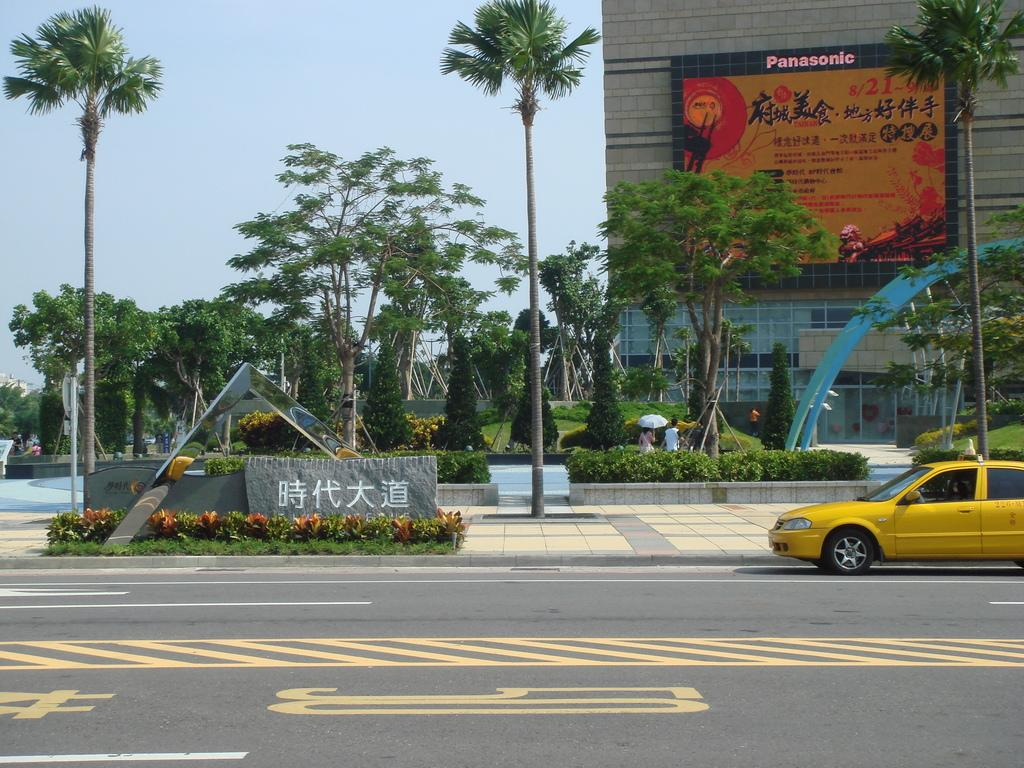<image>
Describe the image concisely. a building with a Panasonic sign at the top 